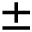Convert formula to latex. <formula><loc_0><loc_0><loc_500><loc_500>\pm</formula> 